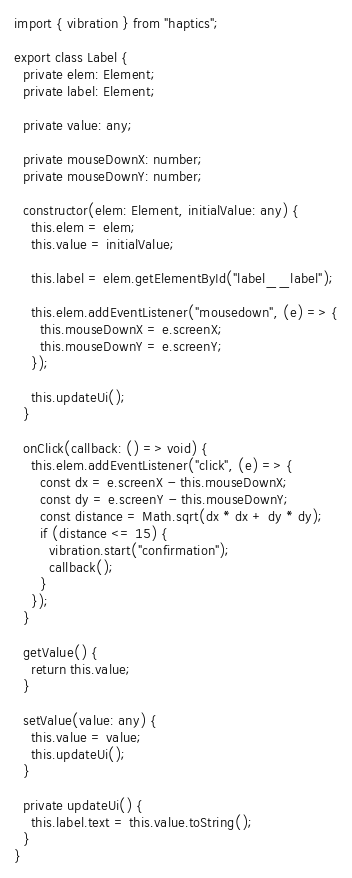<code> <loc_0><loc_0><loc_500><loc_500><_TypeScript_>import { vibration } from "haptics";

export class Label {
  private elem: Element;
  private label: Element;

  private value: any;

  private mouseDownX: number;
  private mouseDownY: number;

  constructor(elem: Element, initialValue: any) {
    this.elem = elem;
    this.value = initialValue;

    this.label = elem.getElementById("label__label");

    this.elem.addEventListener("mousedown", (e) => {
      this.mouseDownX = e.screenX;
      this.mouseDownY = e.screenY;
    });

    this.updateUi();
  }

  onClick(callback: () => void) {
    this.elem.addEventListener("click", (e) => {
      const dx = e.screenX - this.mouseDownX;
      const dy = e.screenY - this.mouseDownY;
      const distance = Math.sqrt(dx * dx + dy * dy);
      if (distance <= 15) {
        vibration.start("confirmation");
        callback();
      }
    });
  }

  getValue() {
    return this.value;
  }

  setValue(value: any) {
    this.value = value;
    this.updateUi();
  }

  private updateUi() {
    this.label.text = this.value.toString();
  }
}
</code> 